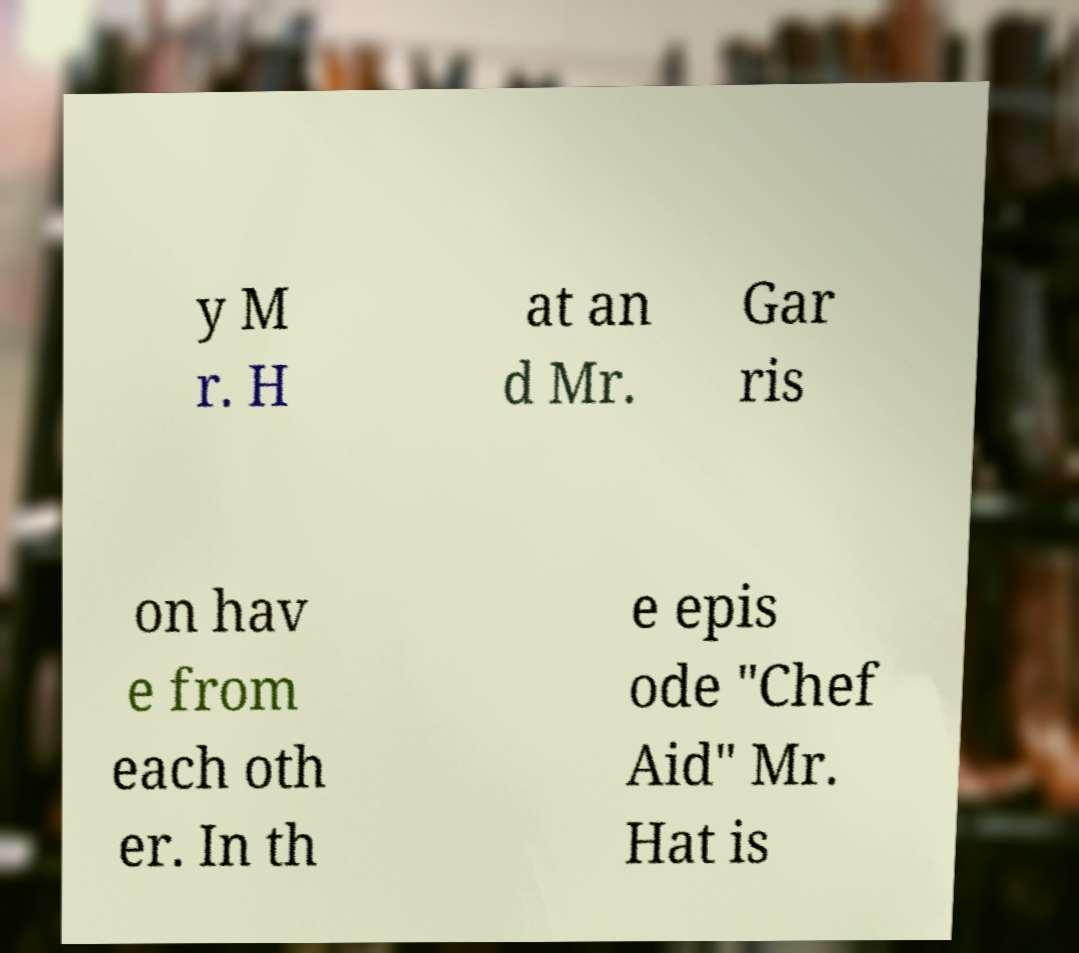Can you accurately transcribe the text from the provided image for me? y M r. H at an d Mr. Gar ris on hav e from each oth er. In th e epis ode "Chef Aid" Mr. Hat is 